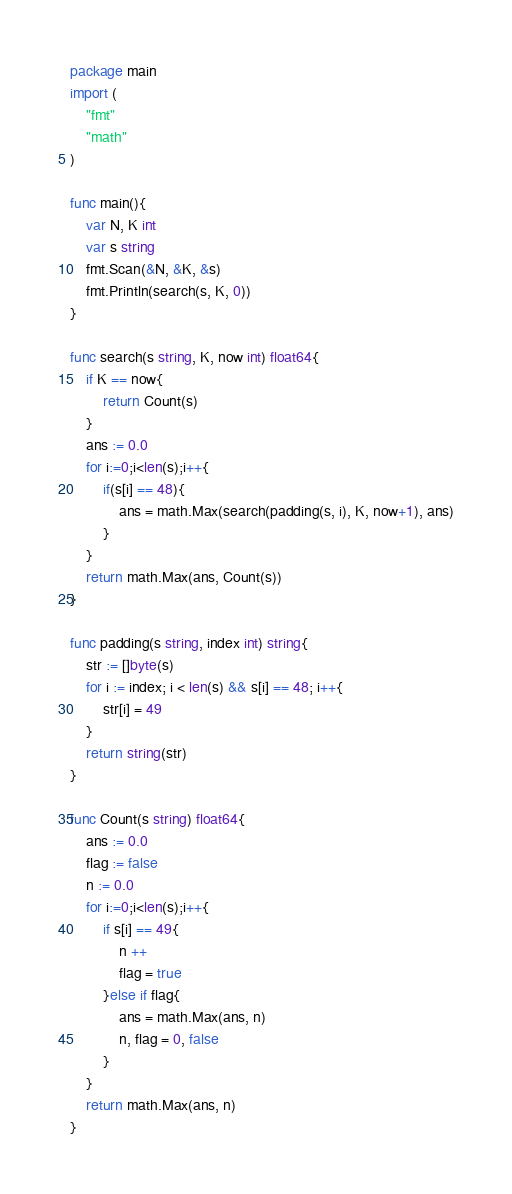<code> <loc_0><loc_0><loc_500><loc_500><_Go_>package main
import (
    "fmt"
    "math"
)

func main(){
    var N, K int
    var s string
    fmt.Scan(&N, &K, &s)
    fmt.Println(search(s, K, 0))
}

func search(s string, K, now int) float64{
    if K == now{
        return Count(s)
    }
    ans := 0.0
    for i:=0;i<len(s);i++{
        if(s[i] == 48){
            ans = math.Max(search(padding(s, i), K, now+1), ans)
        }
    }
    return math.Max(ans, Count(s))
}

func padding(s string, index int) string{
    str := []byte(s)
    for i := index; i < len(s) && s[i] == 48; i++{
        str[i] = 49
    }
    return string(str)
}

func Count(s string) float64{
    ans := 0.0
    flag := false
    n := 0.0
    for i:=0;i<len(s);i++{
        if s[i] == 49{
            n ++
            flag = true
        }else if flag{
            ans = math.Max(ans, n)
            n, flag = 0, false
        }
    }
    return math.Max(ans, n)
}
</code> 